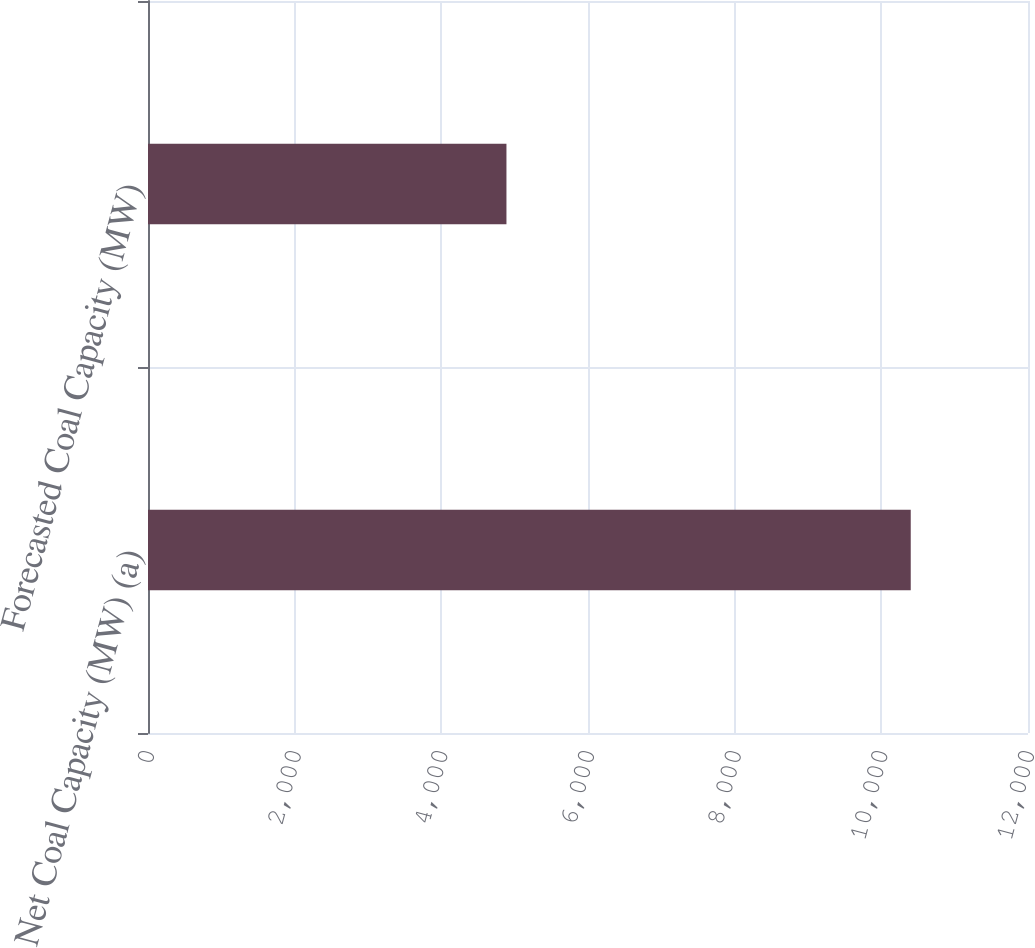Convert chart. <chart><loc_0><loc_0><loc_500><loc_500><bar_chart><fcel>Net Coal Capacity (MW) (a)<fcel>Forecasted Coal Capacity (MW)<nl><fcel>10401<fcel>4888<nl></chart> 